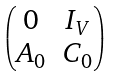<formula> <loc_0><loc_0><loc_500><loc_500>\begin{pmatrix} 0 & I _ { V } \\ { A } _ { 0 } & C _ { 0 } \end{pmatrix}</formula> 